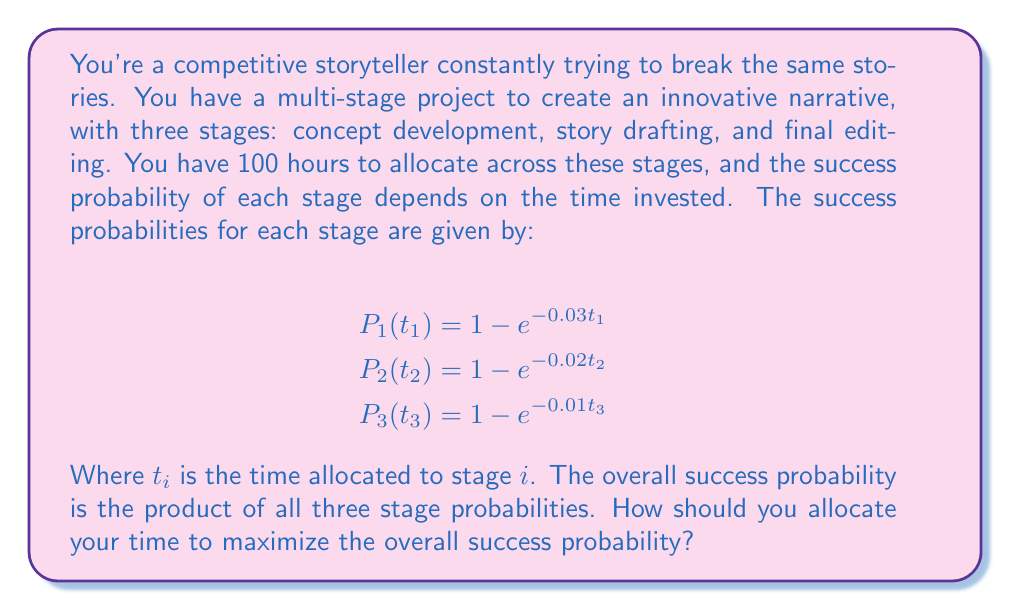Provide a solution to this math problem. To solve this problem, we need to maximize the overall success probability subject to the constraint that the total time allocated is 100 hours. Let's approach this step-by-step:

1) The overall success probability is:

   $$P_{total} = P_1(t_1) \cdot P_2(t_2) \cdot P_3(t_3)$$

2) Substituting the given probabilities:

   $$P_{total} = (1 - e^{-0.03t_1})(1 - e^{-0.02t_2})(1 - e^{-0.01t_3})$$

3) We need to maximize this function subject to the constraint:

   $$t_1 + t_2 + t_3 = 100$$

4) This is a constrained optimization problem. We can solve it using the method of Lagrange multipliers. Let's define the Lagrangian:

   $$L = (1 - e^{-0.03t_1})(1 - e^{-0.02t_2})(1 - e^{-0.01t_3}) - \lambda(t_1 + t_2 + t_3 - 100)$$

5) We then set the partial derivatives of L with respect to $t_1$, $t_2$, $t_3$, and $\lambda$ to zero:

   $$\frac{\partial L}{\partial t_1} = 0.03e^{-0.03t_1}(1 - e^{-0.02t_2})(1 - e^{-0.01t_3}) - \lambda = 0$$
   $$\frac{\partial L}{\partial t_2} = 0.02e^{-0.02t_2}(1 - e^{-0.03t_1})(1 - e^{-0.01t_3}) - \lambda = 0$$
   $$\frac{\partial L}{\partial t_3} = 0.01e^{-0.01t_3}(1 - e^{-0.03t_1})(1 - e^{-0.02t_2}) - \lambda = 0$$
   $$\frac{\partial L}{\partial \lambda} = t_1 + t_2 + t_3 - 100 = 0$$

6) From these equations, we can deduce:

   $$0.03e^{-0.03t_1} = 0.02e^{-0.02t_2} = 0.01e^{-0.01t_3}$$

7) Taking logarithms:

   $$\ln(0.03) - 0.03t_1 = \ln(0.02) - 0.02t_2 = \ln(0.01) - 0.01t_3$$

8) Solving these equations along with the constraint $t_1 + t_2 + t_3 = 100$, we get:

   $$t_1 \approx 46.3 \text{ hours}$$
   $$t_2 \approx 34.7 \text{ hours}$$
   $$t_3 \approx 19.0 \text{ hours}$$

These values maximize the overall success probability.
Answer: The optimal time allocation is approximately:
Concept development (Stage 1): 46.3 hours
Story drafting (Stage 2): 34.7 hours
Final editing (Stage 3): 19.0 hours 